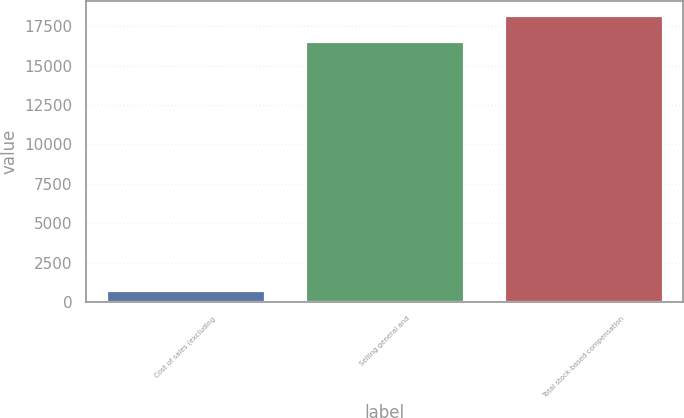Convert chart. <chart><loc_0><loc_0><loc_500><loc_500><bar_chart><fcel>Cost of sales (excluding<fcel>Selling general and<fcel>Total stock-based compensation<nl><fcel>730<fcel>16544<fcel>18198.4<nl></chart> 